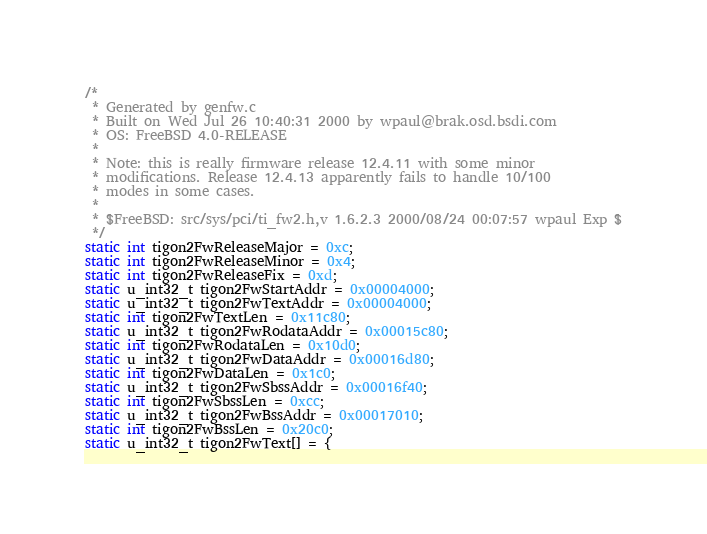<code> <loc_0><loc_0><loc_500><loc_500><_C_>/*
 * Generated by genfw.c
 * Built on Wed Jul 26 10:40:31 2000 by wpaul@brak.osd.bsdi.com
 * OS: FreeBSD 4.0-RELEASE
 *
 * Note: this is really firmware release 12.4.11 with some minor
 * modifications. Release 12.4.13 apparently fails to handle 10/100
 * modes in some cases.
 *
 * $FreeBSD: src/sys/pci/ti_fw2.h,v 1.6.2.3 2000/08/24 00:07:57 wpaul Exp $
 */
static int tigon2FwReleaseMajor = 0xc;
static int tigon2FwReleaseMinor = 0x4;
static int tigon2FwReleaseFix = 0xd;
static u_int32_t tigon2FwStartAddr = 0x00004000;
static u_int32_t tigon2FwTextAddr = 0x00004000;
static int tigon2FwTextLen = 0x11c80;
static u_int32_t tigon2FwRodataAddr = 0x00015c80;
static int tigon2FwRodataLen = 0x10d0;
static u_int32_t tigon2FwDataAddr = 0x00016d80;
static int tigon2FwDataLen = 0x1c0;
static u_int32_t tigon2FwSbssAddr = 0x00016f40;
static int tigon2FwSbssLen = 0xcc;
static u_int32_t tigon2FwBssAddr = 0x00017010;
static int tigon2FwBssLen = 0x20c0;
static u_int32_t tigon2FwText[] = {</code> 